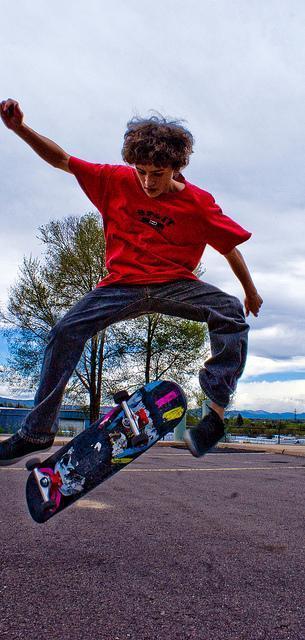How many sheep are facing forward?
Give a very brief answer. 0. 